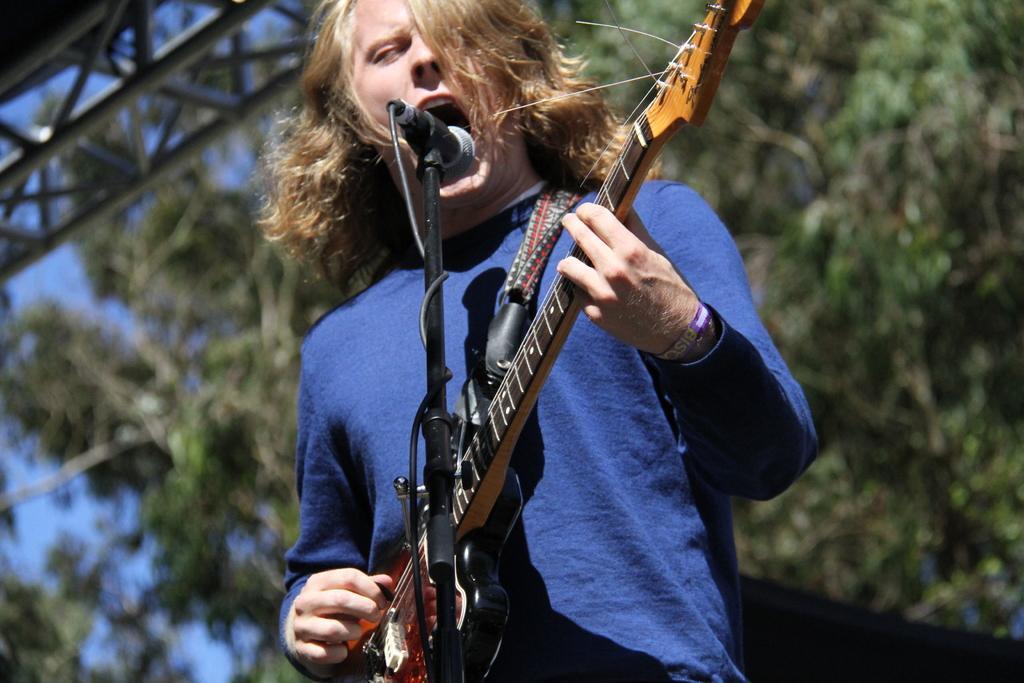In one or two sentences, can you explain what this image depicts? a person is singing holding a guitar. in the front there is a microphone. at the back there are trees. 